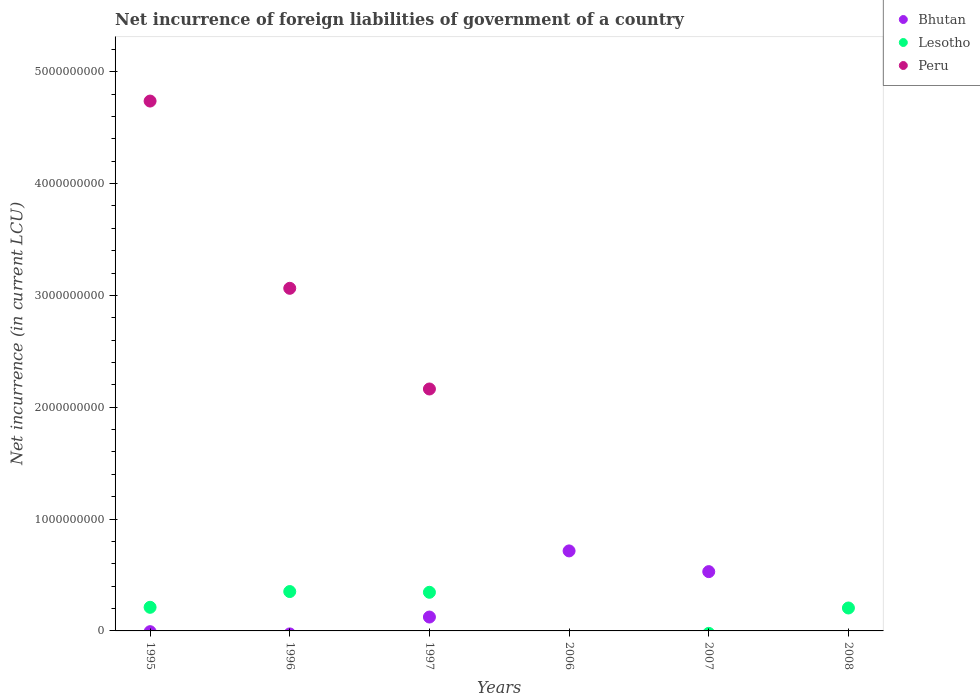What is the net incurrence of foreign liabilities in Peru in 1995?
Your answer should be compact. 4.74e+09. Across all years, what is the maximum net incurrence of foreign liabilities in Peru?
Your answer should be compact. 4.74e+09. What is the total net incurrence of foreign liabilities in Bhutan in the graph?
Give a very brief answer. 1.37e+09. What is the difference between the net incurrence of foreign liabilities in Lesotho in 1995 and that in 1997?
Provide a succinct answer. -1.34e+08. What is the difference between the net incurrence of foreign liabilities in Bhutan in 2006 and the net incurrence of foreign liabilities in Peru in 2007?
Provide a succinct answer. 7.15e+08. What is the average net incurrence of foreign liabilities in Lesotho per year?
Offer a terse response. 1.86e+08. In the year 1995, what is the difference between the net incurrence of foreign liabilities in Peru and net incurrence of foreign liabilities in Lesotho?
Provide a succinct answer. 4.53e+09. What is the ratio of the net incurrence of foreign liabilities in Lesotho in 1996 to that in 1997?
Provide a succinct answer. 1.02. Is the difference between the net incurrence of foreign liabilities in Peru in 1995 and 1996 greater than the difference between the net incurrence of foreign liabilities in Lesotho in 1995 and 1996?
Your answer should be compact. Yes. What is the difference between the highest and the second highest net incurrence of foreign liabilities in Bhutan?
Keep it short and to the point. 1.85e+08. What is the difference between the highest and the lowest net incurrence of foreign liabilities in Peru?
Offer a very short reply. 4.74e+09. In how many years, is the net incurrence of foreign liabilities in Peru greater than the average net incurrence of foreign liabilities in Peru taken over all years?
Your response must be concise. 3. Is the sum of the net incurrence of foreign liabilities in Lesotho in 1997 and 2008 greater than the maximum net incurrence of foreign liabilities in Bhutan across all years?
Provide a succinct answer. No. Does the net incurrence of foreign liabilities in Bhutan monotonically increase over the years?
Your answer should be compact. No. How many dotlines are there?
Your answer should be very brief. 3. How many years are there in the graph?
Ensure brevity in your answer.  6. What is the difference between two consecutive major ticks on the Y-axis?
Offer a very short reply. 1.00e+09. Does the graph contain any zero values?
Provide a short and direct response. Yes. Where does the legend appear in the graph?
Provide a short and direct response. Top right. How many legend labels are there?
Offer a very short reply. 3. What is the title of the graph?
Your answer should be compact. Net incurrence of foreign liabilities of government of a country. What is the label or title of the X-axis?
Offer a terse response. Years. What is the label or title of the Y-axis?
Your response must be concise. Net incurrence (in current LCU). What is the Net incurrence (in current LCU) in Lesotho in 1995?
Give a very brief answer. 2.11e+08. What is the Net incurrence (in current LCU) in Peru in 1995?
Offer a terse response. 4.74e+09. What is the Net incurrence (in current LCU) of Lesotho in 1996?
Your answer should be compact. 3.52e+08. What is the Net incurrence (in current LCU) of Peru in 1996?
Your answer should be very brief. 3.06e+09. What is the Net incurrence (in current LCU) of Bhutan in 1997?
Your answer should be compact. 1.24e+08. What is the Net incurrence (in current LCU) of Lesotho in 1997?
Offer a terse response. 3.46e+08. What is the Net incurrence (in current LCU) in Peru in 1997?
Give a very brief answer. 2.16e+09. What is the Net incurrence (in current LCU) in Bhutan in 2006?
Give a very brief answer. 7.15e+08. What is the Net incurrence (in current LCU) of Bhutan in 2007?
Your answer should be compact. 5.30e+08. What is the Net incurrence (in current LCU) of Lesotho in 2007?
Ensure brevity in your answer.  0. What is the Net incurrence (in current LCU) in Bhutan in 2008?
Make the answer very short. 0. What is the Net incurrence (in current LCU) of Lesotho in 2008?
Your response must be concise. 2.05e+08. Across all years, what is the maximum Net incurrence (in current LCU) of Bhutan?
Provide a succinct answer. 7.15e+08. Across all years, what is the maximum Net incurrence (in current LCU) in Lesotho?
Provide a succinct answer. 3.52e+08. Across all years, what is the maximum Net incurrence (in current LCU) of Peru?
Your answer should be compact. 4.74e+09. Across all years, what is the minimum Net incurrence (in current LCU) in Peru?
Offer a very short reply. 0. What is the total Net incurrence (in current LCU) of Bhutan in the graph?
Your response must be concise. 1.37e+09. What is the total Net incurrence (in current LCU) in Lesotho in the graph?
Offer a terse response. 1.11e+09. What is the total Net incurrence (in current LCU) of Peru in the graph?
Ensure brevity in your answer.  9.97e+09. What is the difference between the Net incurrence (in current LCU) of Lesotho in 1995 and that in 1996?
Your answer should be compact. -1.41e+08. What is the difference between the Net incurrence (in current LCU) of Peru in 1995 and that in 1996?
Ensure brevity in your answer.  1.67e+09. What is the difference between the Net incurrence (in current LCU) in Lesotho in 1995 and that in 1997?
Offer a very short reply. -1.34e+08. What is the difference between the Net incurrence (in current LCU) in Peru in 1995 and that in 1997?
Offer a very short reply. 2.57e+09. What is the difference between the Net incurrence (in current LCU) of Lesotho in 1995 and that in 2008?
Provide a short and direct response. 6.10e+06. What is the difference between the Net incurrence (in current LCU) of Lesotho in 1996 and that in 1997?
Provide a succinct answer. 6.50e+06. What is the difference between the Net incurrence (in current LCU) in Peru in 1996 and that in 1997?
Ensure brevity in your answer.  9.00e+08. What is the difference between the Net incurrence (in current LCU) in Lesotho in 1996 and that in 2008?
Give a very brief answer. 1.47e+08. What is the difference between the Net incurrence (in current LCU) in Bhutan in 1997 and that in 2006?
Provide a short and direct response. -5.91e+08. What is the difference between the Net incurrence (in current LCU) of Bhutan in 1997 and that in 2007?
Provide a succinct answer. -4.06e+08. What is the difference between the Net incurrence (in current LCU) of Lesotho in 1997 and that in 2008?
Offer a very short reply. 1.40e+08. What is the difference between the Net incurrence (in current LCU) in Bhutan in 2006 and that in 2007?
Make the answer very short. 1.85e+08. What is the difference between the Net incurrence (in current LCU) of Lesotho in 1995 and the Net incurrence (in current LCU) of Peru in 1996?
Ensure brevity in your answer.  -2.85e+09. What is the difference between the Net incurrence (in current LCU) of Lesotho in 1995 and the Net incurrence (in current LCU) of Peru in 1997?
Make the answer very short. -1.95e+09. What is the difference between the Net incurrence (in current LCU) in Lesotho in 1996 and the Net incurrence (in current LCU) in Peru in 1997?
Offer a terse response. -1.81e+09. What is the difference between the Net incurrence (in current LCU) of Bhutan in 1997 and the Net incurrence (in current LCU) of Lesotho in 2008?
Offer a very short reply. -8.09e+07. What is the difference between the Net incurrence (in current LCU) in Bhutan in 2006 and the Net incurrence (in current LCU) in Lesotho in 2008?
Your answer should be very brief. 5.10e+08. What is the difference between the Net incurrence (in current LCU) in Bhutan in 2007 and the Net incurrence (in current LCU) in Lesotho in 2008?
Keep it short and to the point. 3.25e+08. What is the average Net incurrence (in current LCU) of Bhutan per year?
Offer a terse response. 2.28e+08. What is the average Net incurrence (in current LCU) in Lesotho per year?
Your answer should be very brief. 1.86e+08. What is the average Net incurrence (in current LCU) in Peru per year?
Your answer should be very brief. 1.66e+09. In the year 1995, what is the difference between the Net incurrence (in current LCU) of Lesotho and Net incurrence (in current LCU) of Peru?
Give a very brief answer. -4.53e+09. In the year 1996, what is the difference between the Net incurrence (in current LCU) of Lesotho and Net incurrence (in current LCU) of Peru?
Provide a succinct answer. -2.71e+09. In the year 1997, what is the difference between the Net incurrence (in current LCU) in Bhutan and Net incurrence (in current LCU) in Lesotho?
Your answer should be compact. -2.21e+08. In the year 1997, what is the difference between the Net incurrence (in current LCU) of Bhutan and Net incurrence (in current LCU) of Peru?
Your answer should be very brief. -2.04e+09. In the year 1997, what is the difference between the Net incurrence (in current LCU) of Lesotho and Net incurrence (in current LCU) of Peru?
Your answer should be compact. -1.82e+09. What is the ratio of the Net incurrence (in current LCU) of Peru in 1995 to that in 1996?
Your answer should be compact. 1.55. What is the ratio of the Net incurrence (in current LCU) in Lesotho in 1995 to that in 1997?
Make the answer very short. 0.61. What is the ratio of the Net incurrence (in current LCU) of Peru in 1995 to that in 1997?
Your answer should be compact. 2.19. What is the ratio of the Net incurrence (in current LCU) of Lesotho in 1995 to that in 2008?
Keep it short and to the point. 1.03. What is the ratio of the Net incurrence (in current LCU) in Lesotho in 1996 to that in 1997?
Offer a very short reply. 1.02. What is the ratio of the Net incurrence (in current LCU) of Peru in 1996 to that in 1997?
Provide a short and direct response. 1.42. What is the ratio of the Net incurrence (in current LCU) of Lesotho in 1996 to that in 2008?
Your answer should be compact. 1.72. What is the ratio of the Net incurrence (in current LCU) in Bhutan in 1997 to that in 2006?
Give a very brief answer. 0.17. What is the ratio of the Net incurrence (in current LCU) in Bhutan in 1997 to that in 2007?
Your answer should be compact. 0.23. What is the ratio of the Net incurrence (in current LCU) in Lesotho in 1997 to that in 2008?
Offer a terse response. 1.68. What is the ratio of the Net incurrence (in current LCU) of Bhutan in 2006 to that in 2007?
Provide a short and direct response. 1.35. What is the difference between the highest and the second highest Net incurrence (in current LCU) of Bhutan?
Your answer should be very brief. 1.85e+08. What is the difference between the highest and the second highest Net incurrence (in current LCU) of Lesotho?
Your answer should be compact. 6.50e+06. What is the difference between the highest and the second highest Net incurrence (in current LCU) in Peru?
Provide a short and direct response. 1.67e+09. What is the difference between the highest and the lowest Net incurrence (in current LCU) in Bhutan?
Keep it short and to the point. 7.15e+08. What is the difference between the highest and the lowest Net incurrence (in current LCU) of Lesotho?
Your answer should be very brief. 3.52e+08. What is the difference between the highest and the lowest Net incurrence (in current LCU) of Peru?
Your answer should be compact. 4.74e+09. 